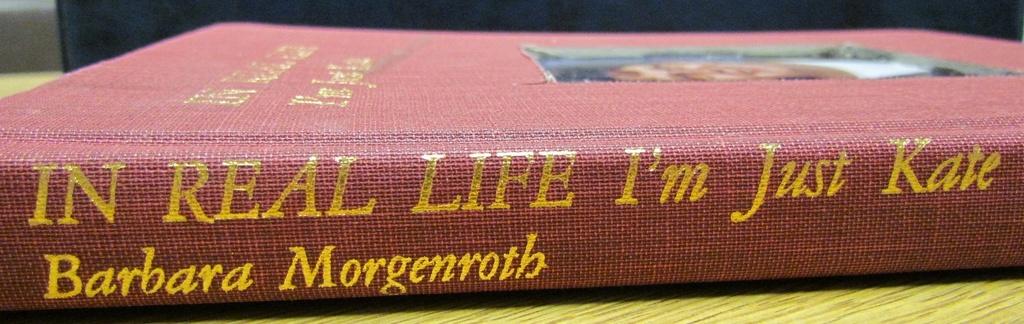Who's the author of this book?
Offer a very short reply. Barbara morgenroth. What is the title of the book?
Ensure brevity in your answer.  In real life i'm just kate. 